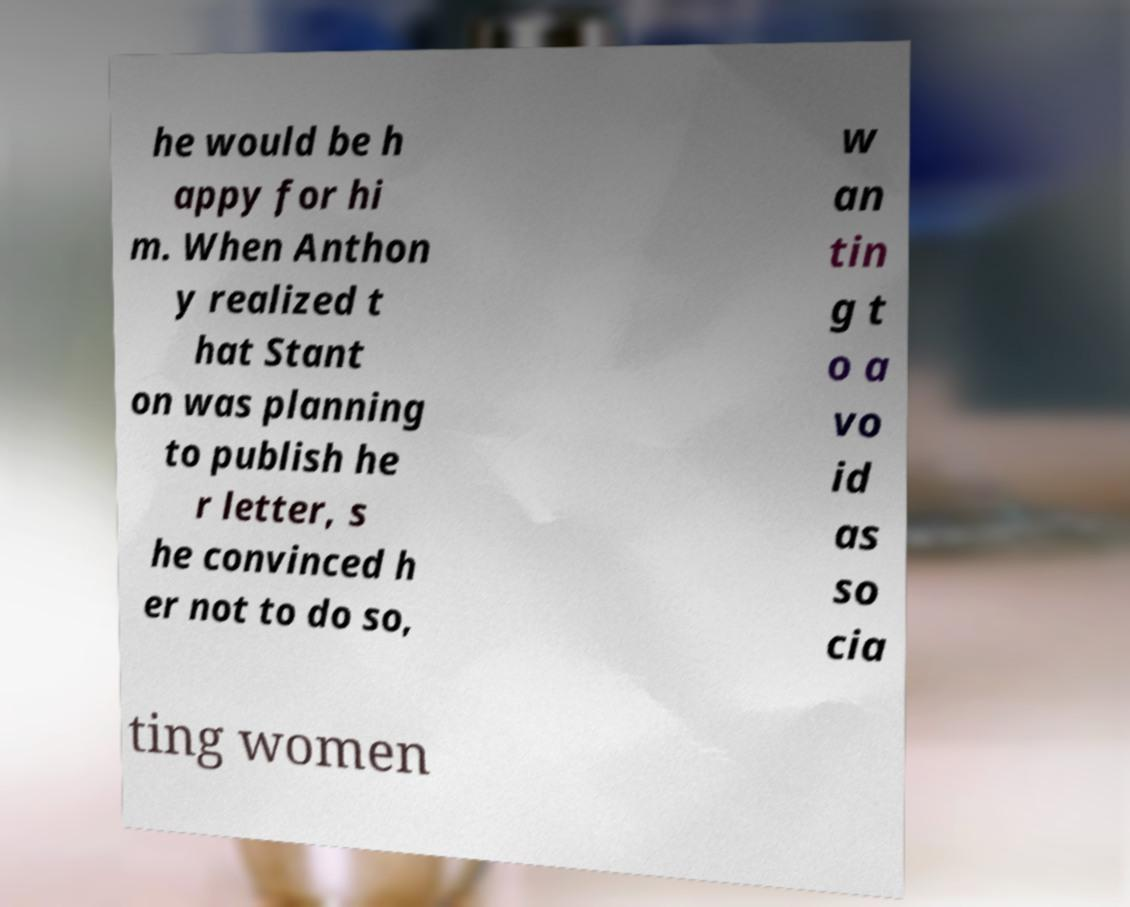Can you accurately transcribe the text from the provided image for me? he would be h appy for hi m. When Anthon y realized t hat Stant on was planning to publish he r letter, s he convinced h er not to do so, w an tin g t o a vo id as so cia ting women 